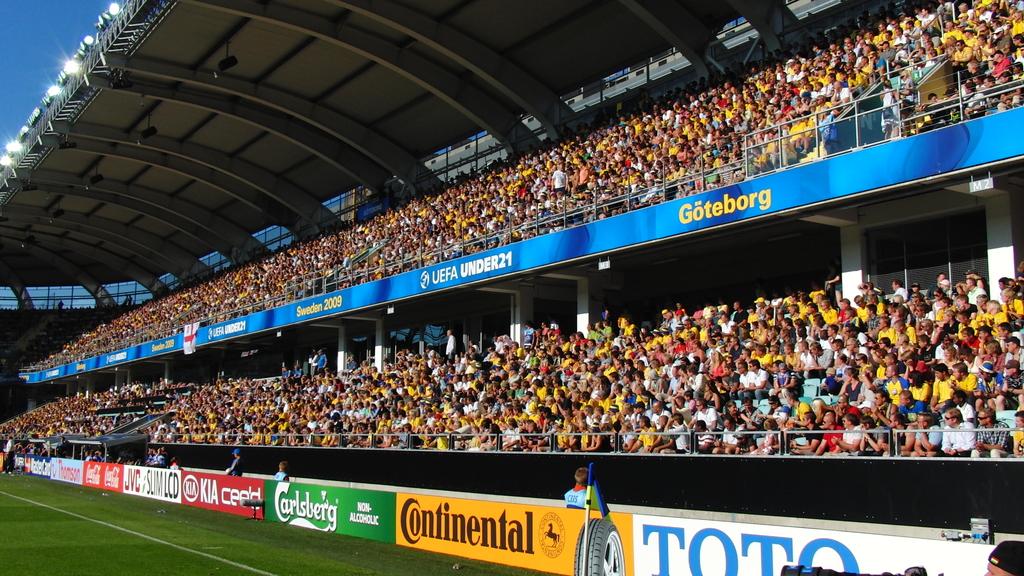What sponsor has a yellow sign?
Your answer should be compact. Continental. 